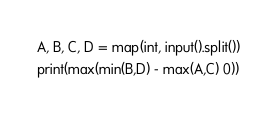Convert code to text. <code><loc_0><loc_0><loc_500><loc_500><_Python_>A, B, C, D = map(int, input().split())
print(max(min(B,D) - max(A,C) 0))
</code> 